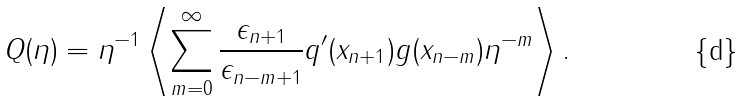<formula> <loc_0><loc_0><loc_500><loc_500>Q ( \eta ) = \eta ^ { - 1 } \left < \sum _ { m = 0 } ^ { \infty } \frac { \epsilon _ { n + 1 } } { \epsilon _ { n - m + 1 } } q ^ { \prime } ( x _ { n + 1 } ) g ( x _ { n - m } ) \eta ^ { - m } \right > .</formula> 